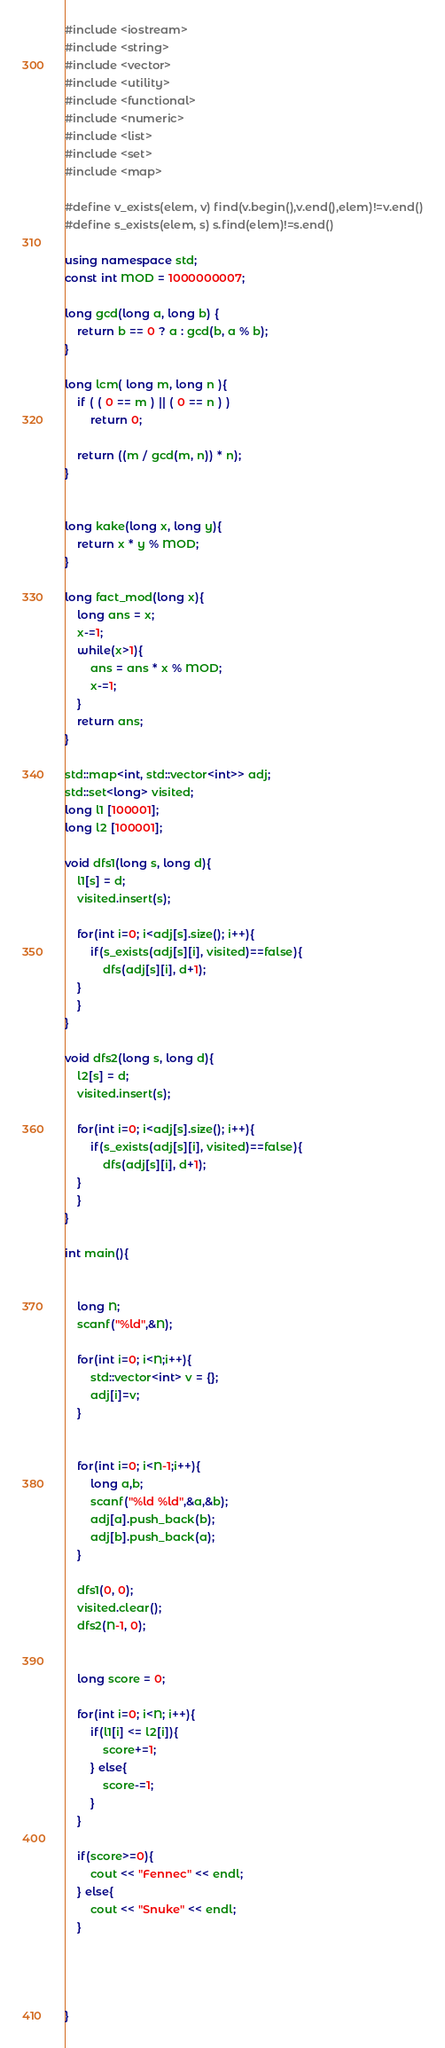<code> <loc_0><loc_0><loc_500><loc_500><_C++_>#include <iostream>
#include <string>
#include <vector>
#include <utility>
#include <functional>
#include <numeric>
#include <list>
#include <set>
#include <map>

#define v_exists(elem, v) find(v.begin(),v.end(),elem)!=v.end()
#define s_exists(elem, s) s.find(elem)!=s.end()

using namespace std;
const int MOD = 1000000007;

long gcd(long a, long b) {
    return b == 0 ? a : gcd(b, a % b);
}

long lcm( long m, long n ){
	if ( ( 0 == m ) || ( 0 == n ) )
		return 0;

	return ((m / gcd(m, n)) * n);
}


long kake(long x, long y){
	return x * y % MOD;
}

long fact_mod(long x){
	long ans = x;
	x-=1;
	while(x>1){
		ans = ans * x % MOD;
		x-=1;
	}
	return ans;
}

std::map<int, std::vector<int>> adj;
std::set<long> visited;
long l1 [100001];
long l2 [100001];

void dfs1(long s, long d){
	l1[s] = d;
	visited.insert(s);

	for(int i=0; i<adj[s].size(); i++){
		if(s_exists(adj[s][i], visited)==false){
			dfs(adj[s][i], d+1);
	}
	}
}

void dfs2(long s, long d){
	l2[s] = d;
	visited.insert(s);

	for(int i=0; i<adj[s].size(); i++){
		if(s_exists(adj[s][i], visited)==false){
			dfs(adj[s][i], d+1);
	}
	}
}

int main(){


	long N;
	scanf("%ld",&N);

	for(int i=0; i<N;i++){
		std::vector<int> v = {};
		adj[i]=v;
	}


	for(int i=0; i<N-1;i++){
		long a,b;
		scanf("%ld %ld",&a,&b);
		adj[a].push_back(b);
		adj[b].push_back(a);
	}

	dfs1(0, 0);
	visited.clear();
	dfs2(N-1, 0);


	long score = 0;

	for(int i=0; i<N; i++){
		if(l1[i] <= l2[i]){
			score+=1;
		} else{
			score-=1;
		}
	}

	if(score>=0){
		cout << "Fennec" << endl;
	} else{
		cout << "Snuke" << endl;
	}




}</code> 